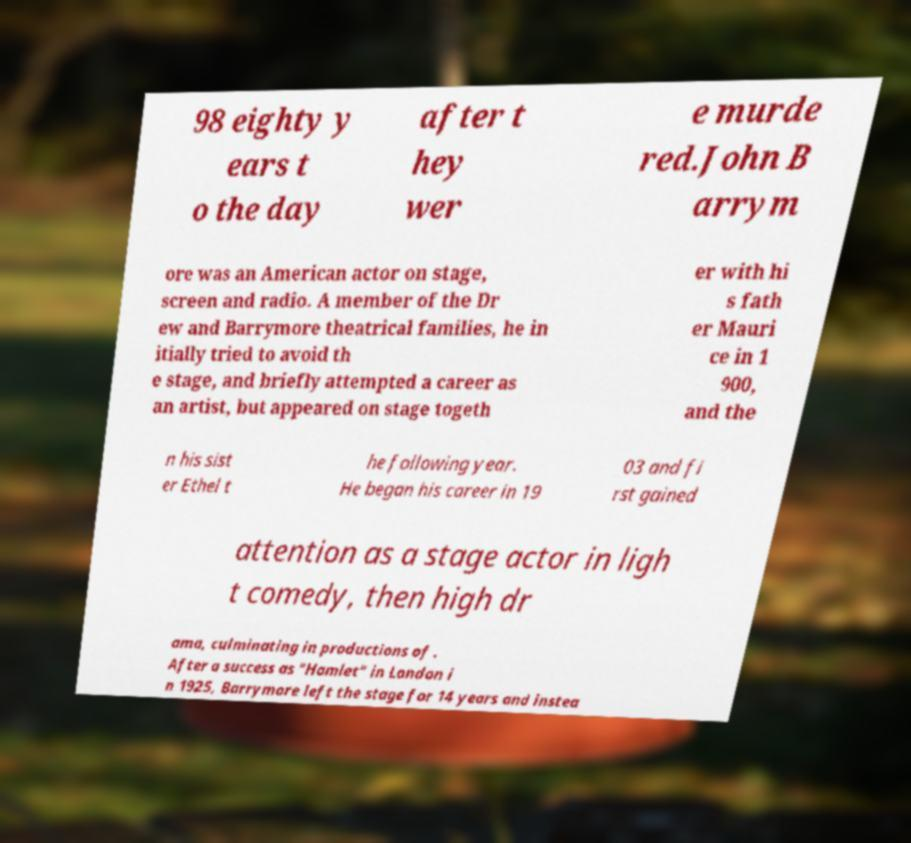Could you assist in decoding the text presented in this image and type it out clearly? 98 eighty y ears t o the day after t hey wer e murde red.John B arrym ore was an American actor on stage, screen and radio. A member of the Dr ew and Barrymore theatrical families, he in itially tried to avoid th e stage, and briefly attempted a career as an artist, but appeared on stage togeth er with hi s fath er Mauri ce in 1 900, and the n his sist er Ethel t he following year. He began his career in 19 03 and fi rst gained attention as a stage actor in ligh t comedy, then high dr ama, culminating in productions of . After a success as "Hamlet" in London i n 1925, Barrymore left the stage for 14 years and instea 